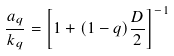<formula> <loc_0><loc_0><loc_500><loc_500>\frac { a _ { q } } { k _ { q } } = \left [ 1 + ( 1 - q ) \frac { D } { 2 } \right ] ^ { - 1 }</formula> 